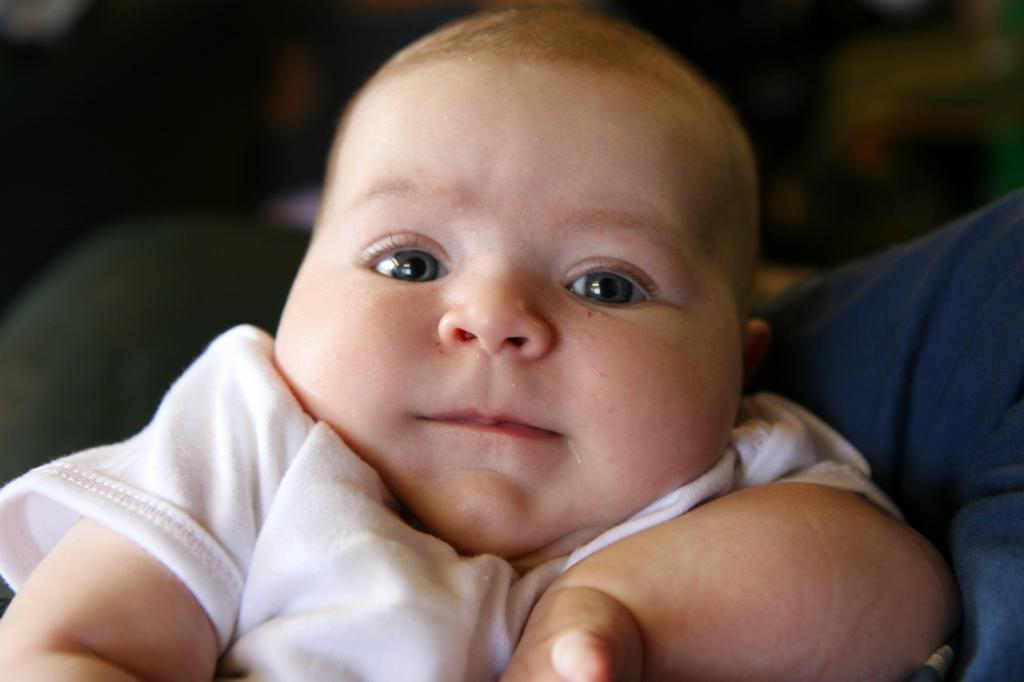What is the main subject of the image? There is a child in the image. What is the child wearing? The child is wearing a white dress. Can you describe the background of the image? The background of the image is blurred. What word is the child trying to spell in the image? There is no indication in the image that the child is trying to spell a word. 